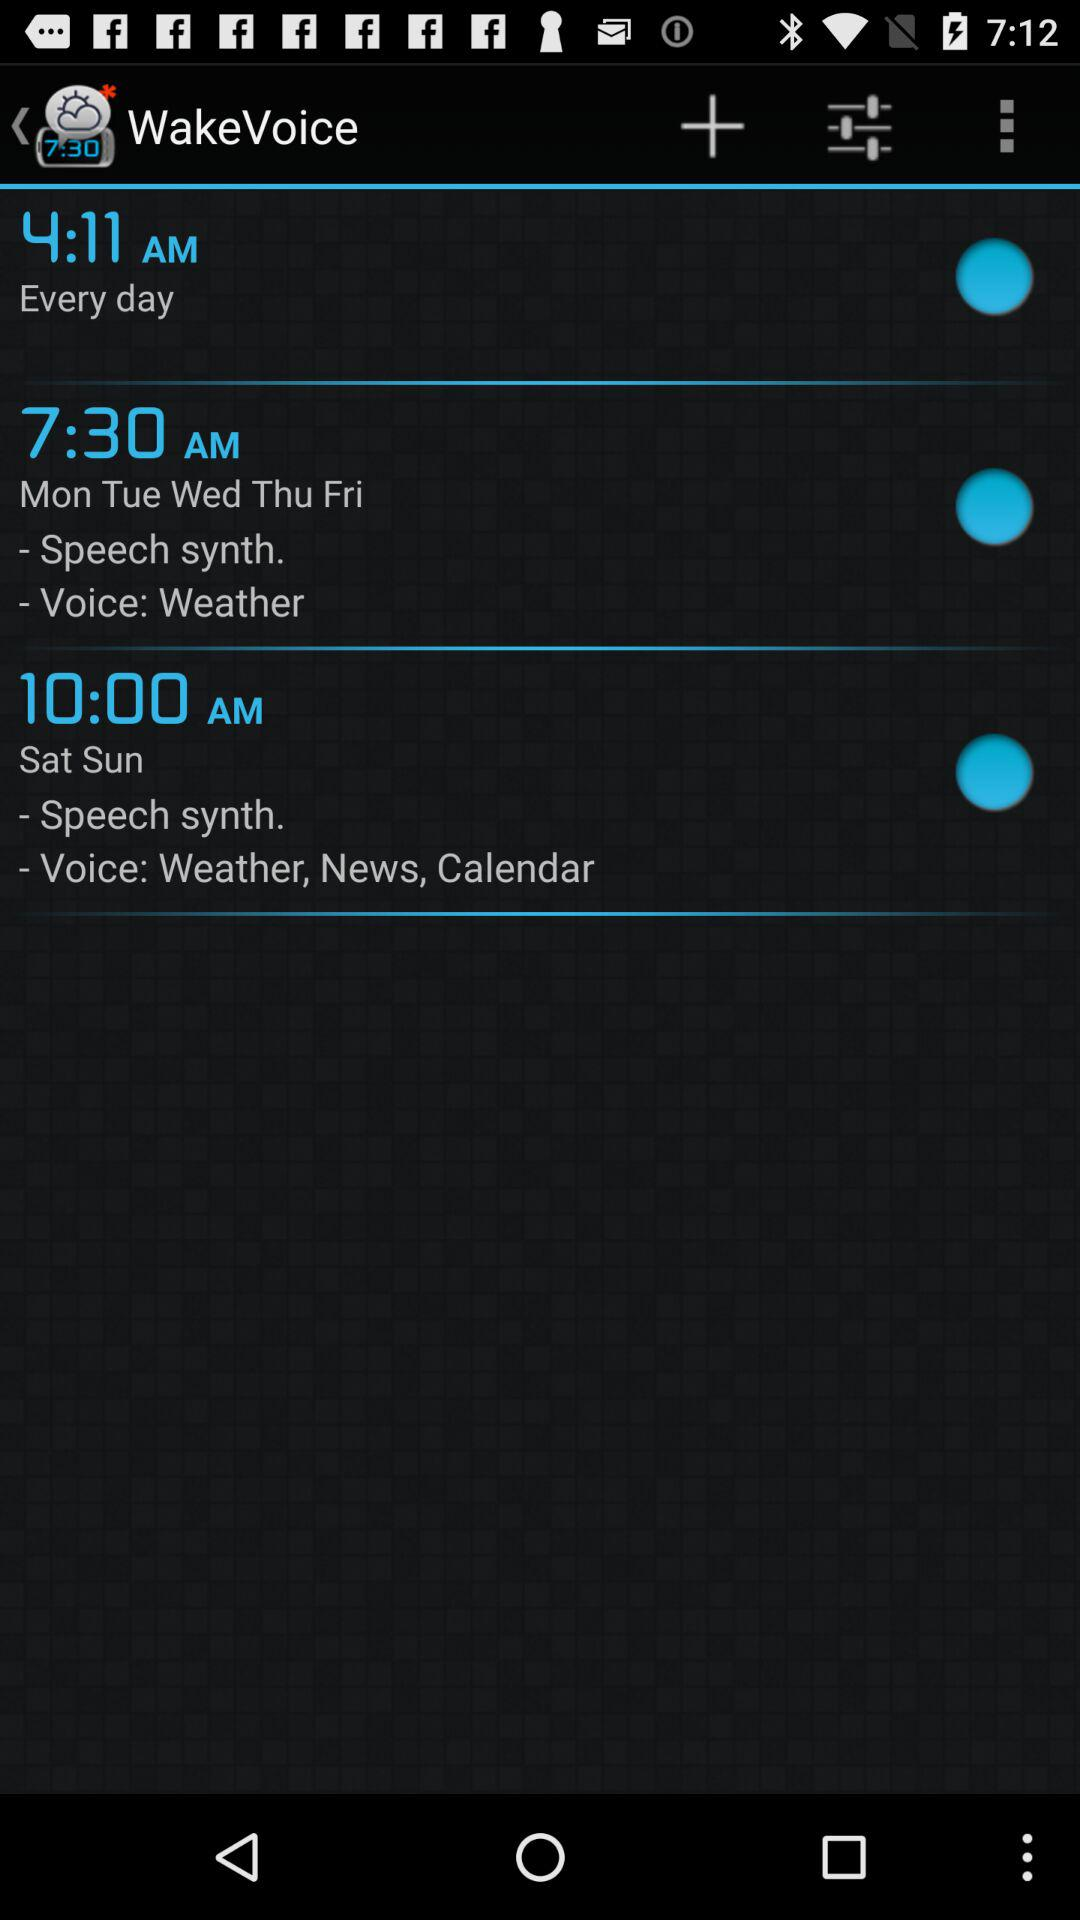At what time is "WakeVoice" set for every day? "WakeVoice" is set at 4:11 AM for every day. 